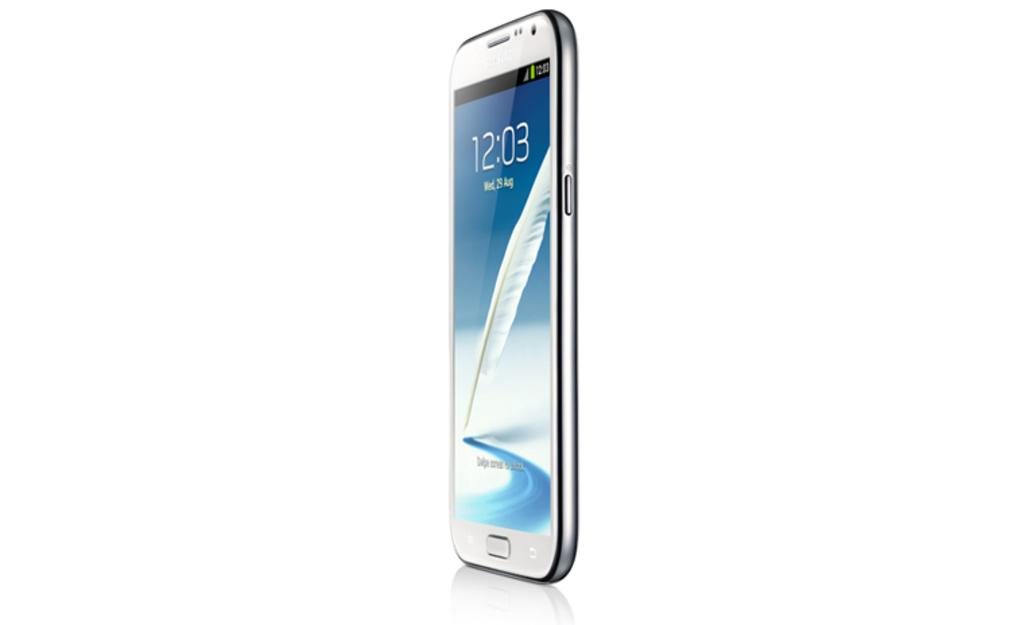<image>
Give a short and clear explanation of the subsequent image. A white smart phone displays the time as 12:03 on its screen. 